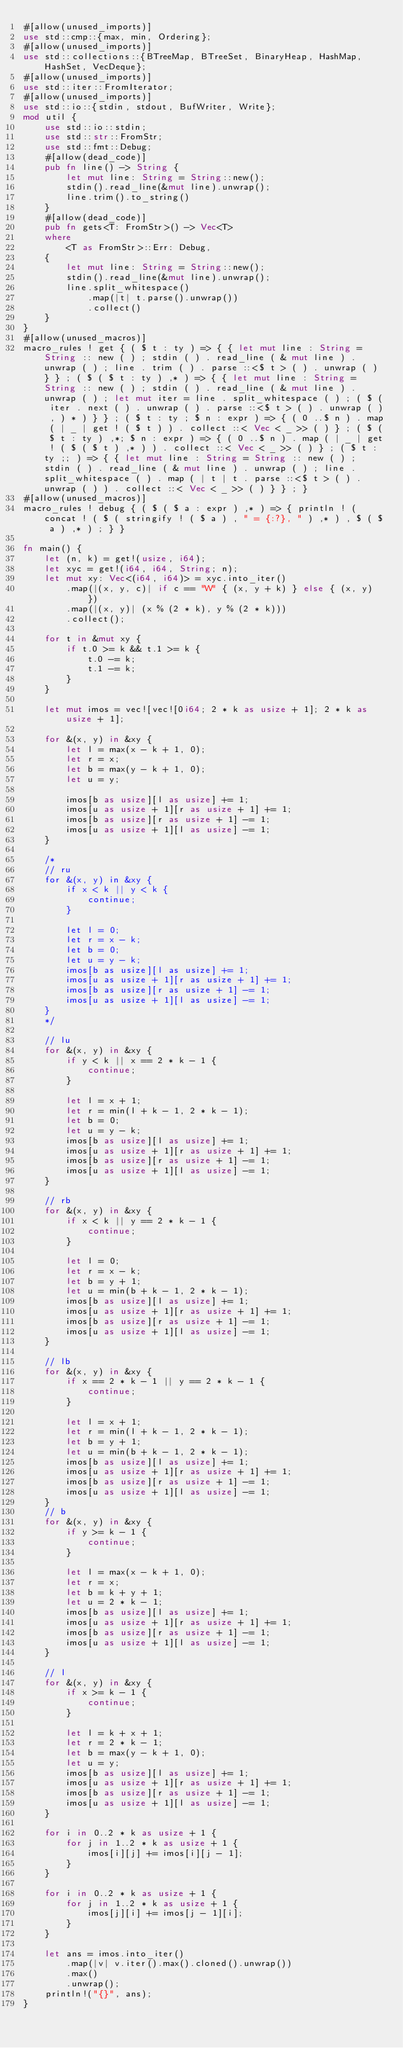Convert code to text. <code><loc_0><loc_0><loc_500><loc_500><_Rust_>#[allow(unused_imports)]
use std::cmp::{max, min, Ordering};
#[allow(unused_imports)]
use std::collections::{BTreeMap, BTreeSet, BinaryHeap, HashMap, HashSet, VecDeque};
#[allow(unused_imports)]
use std::iter::FromIterator;
#[allow(unused_imports)]
use std::io::{stdin, stdout, BufWriter, Write};
mod util {
    use std::io::stdin;
    use std::str::FromStr;
    use std::fmt::Debug;
    #[allow(dead_code)]
    pub fn line() -> String {
        let mut line: String = String::new();
        stdin().read_line(&mut line).unwrap();
        line.trim().to_string()
    }
    #[allow(dead_code)]
    pub fn gets<T: FromStr>() -> Vec<T>
    where
        <T as FromStr>::Err: Debug,
    {
        let mut line: String = String::new();
        stdin().read_line(&mut line).unwrap();
        line.split_whitespace()
            .map(|t| t.parse().unwrap())
            .collect()
    }
}
#[allow(unused_macros)]
macro_rules ! get { ( $ t : ty ) => { { let mut line : String = String :: new ( ) ; stdin ( ) . read_line ( & mut line ) . unwrap ( ) ; line . trim ( ) . parse ::<$ t > ( ) . unwrap ( ) } } ; ( $ ( $ t : ty ) ,* ) => { { let mut line : String = String :: new ( ) ; stdin ( ) . read_line ( & mut line ) . unwrap ( ) ; let mut iter = line . split_whitespace ( ) ; ( $ ( iter . next ( ) . unwrap ( ) . parse ::<$ t > ( ) . unwrap ( ) , ) * ) } } ; ( $ t : ty ; $ n : expr ) => { ( 0 ..$ n ) . map ( | _ | get ! ( $ t ) ) . collect ::< Vec < _ >> ( ) } ; ( $ ( $ t : ty ) ,*; $ n : expr ) => { ( 0 ..$ n ) . map ( | _ | get ! ( $ ( $ t ) ,* ) ) . collect ::< Vec < _ >> ( ) } ; ( $ t : ty ;; ) => { { let mut line : String = String :: new ( ) ; stdin ( ) . read_line ( & mut line ) . unwrap ( ) ; line . split_whitespace ( ) . map ( | t | t . parse ::<$ t > ( ) . unwrap ( ) ) . collect ::< Vec < _ >> ( ) } } ; }
#[allow(unused_macros)]
macro_rules ! debug { ( $ ( $ a : expr ) ,* ) => { println ! ( concat ! ( $ ( stringify ! ( $ a ) , " = {:?}, " ) ,* ) , $ ( $ a ) ,* ) ; } }

fn main() {
    let (n, k) = get!(usize, i64);
    let xyc = get!(i64, i64, String; n);
    let mut xy: Vec<(i64, i64)> = xyc.into_iter()
        .map(|(x, y, c)| if c == "W" { (x, y + k) } else { (x, y) })
        .map(|(x, y)| (x % (2 * k), y % (2 * k)))
        .collect();

    for t in &mut xy {
        if t.0 >= k && t.1 >= k {
            t.0 -= k;
            t.1 -= k;
        }
    }

    let mut imos = vec![vec![0i64; 2 * k as usize + 1]; 2 * k as usize + 1];

    for &(x, y) in &xy {
        let l = max(x - k + 1, 0);
        let r = x;
        let b = max(y - k + 1, 0);
        let u = y;

        imos[b as usize][l as usize] += 1;
        imos[u as usize + 1][r as usize + 1] += 1;
        imos[b as usize][r as usize + 1] -= 1;
        imos[u as usize + 1][l as usize] -= 1;
    }

    /*
    // ru
    for &(x, y) in &xy {
        if x < k || y < k {
            continue;
        }

        let l = 0;
        let r = x - k;
        let b = 0;
        let u = y - k;
        imos[b as usize][l as usize] += 1;
        imos[u as usize + 1][r as usize + 1] += 1;
        imos[b as usize][r as usize + 1] -= 1;
        imos[u as usize + 1][l as usize] -= 1;
    }
    */

    // lu
    for &(x, y) in &xy {
        if y < k || x == 2 * k - 1 {
            continue;
        }

        let l = x + 1;
        let r = min(l + k - 1, 2 * k - 1);
        let b = 0;
        let u = y - k;
        imos[b as usize][l as usize] += 1;
        imos[u as usize + 1][r as usize + 1] += 1;
        imos[b as usize][r as usize + 1] -= 1;
        imos[u as usize + 1][l as usize] -= 1;
    }

    // rb
    for &(x, y) in &xy {
        if x < k || y == 2 * k - 1 {
            continue;
        }

        let l = 0;
        let r = x - k;
        let b = y + 1;
        let u = min(b + k - 1, 2 * k - 1);
        imos[b as usize][l as usize] += 1;
        imos[u as usize + 1][r as usize + 1] += 1;
        imos[b as usize][r as usize + 1] -= 1;
        imos[u as usize + 1][l as usize] -= 1;
    }

    // lb
    for &(x, y) in &xy {
        if x == 2 * k - 1 || y == 2 * k - 1 {
            continue;
        }

        let l = x + 1;
        let r = min(l + k - 1, 2 * k - 1);
        let b = y + 1;
        let u = min(b + k - 1, 2 * k - 1);
        imos[b as usize][l as usize] += 1;
        imos[u as usize + 1][r as usize + 1] += 1;
        imos[b as usize][r as usize + 1] -= 1;
        imos[u as usize + 1][l as usize] -= 1;
    }
    // b
    for &(x, y) in &xy {
        if y >= k - 1 {
            continue;
        }

        let l = max(x - k + 1, 0);
        let r = x;
        let b = k + y + 1;
        let u = 2 * k - 1;
        imos[b as usize][l as usize] += 1;
        imos[u as usize + 1][r as usize + 1] += 1;
        imos[b as usize][r as usize + 1] -= 1;
        imos[u as usize + 1][l as usize] -= 1;
    }

    // l
    for &(x, y) in &xy {
        if x >= k - 1 {
            continue;
        }

        let l = k + x + 1;
        let r = 2 * k - 1;
        let b = max(y - k + 1, 0);
        let u = y;
        imos[b as usize][l as usize] += 1;
        imos[u as usize + 1][r as usize + 1] += 1;
        imos[b as usize][r as usize + 1] -= 1;
        imos[u as usize + 1][l as usize] -= 1;
    }

    for i in 0..2 * k as usize + 1 {
        for j in 1..2 * k as usize + 1 {
            imos[i][j] += imos[i][j - 1];
        }
    }

    for i in 0..2 * k as usize + 1 {
        for j in 1..2 * k as usize + 1 {
            imos[j][i] += imos[j - 1][i];
        }
    }

    let ans = imos.into_iter()
        .map(|v| v.iter().max().cloned().unwrap())
        .max()
        .unwrap();
    println!("{}", ans);
}
</code> 